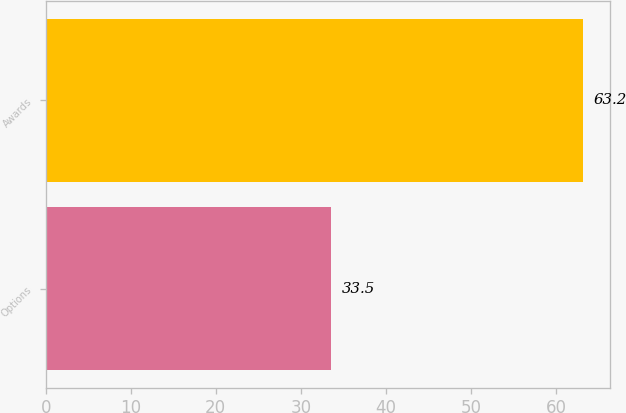Convert chart to OTSL. <chart><loc_0><loc_0><loc_500><loc_500><bar_chart><fcel>Options<fcel>Awards<nl><fcel>33.5<fcel>63.2<nl></chart> 